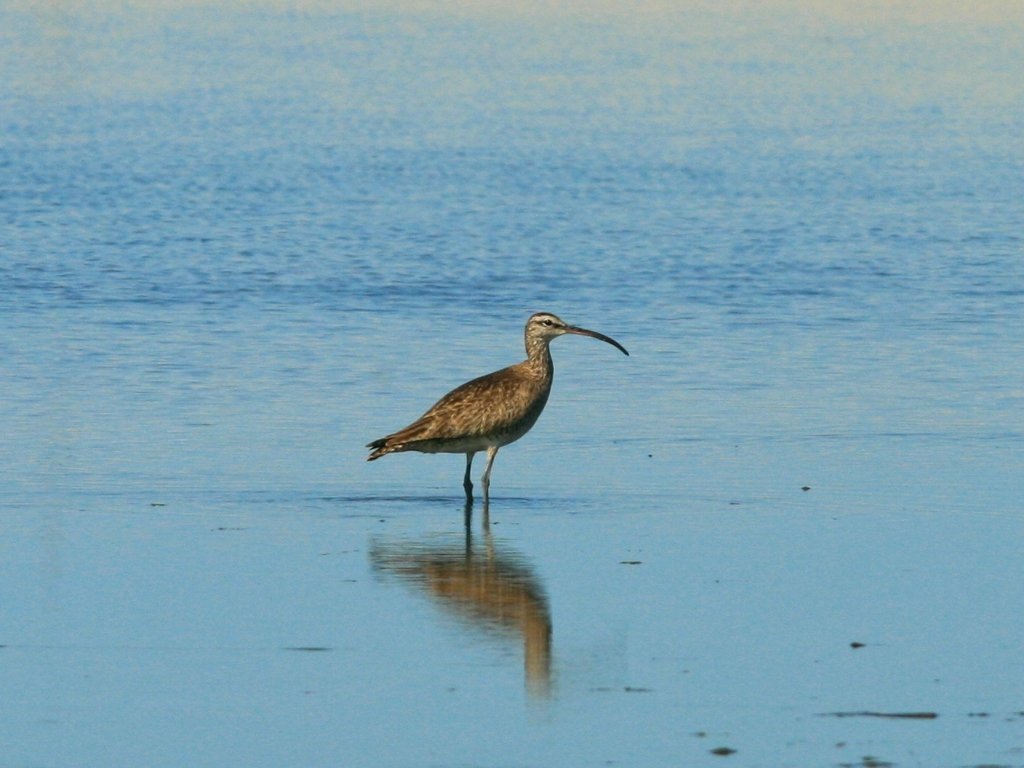How would you describe the clarity of the image?
A. Low
B. Excellent
C. Average
D. High
Answer with the option's letter from the given choices directly.
 D. 